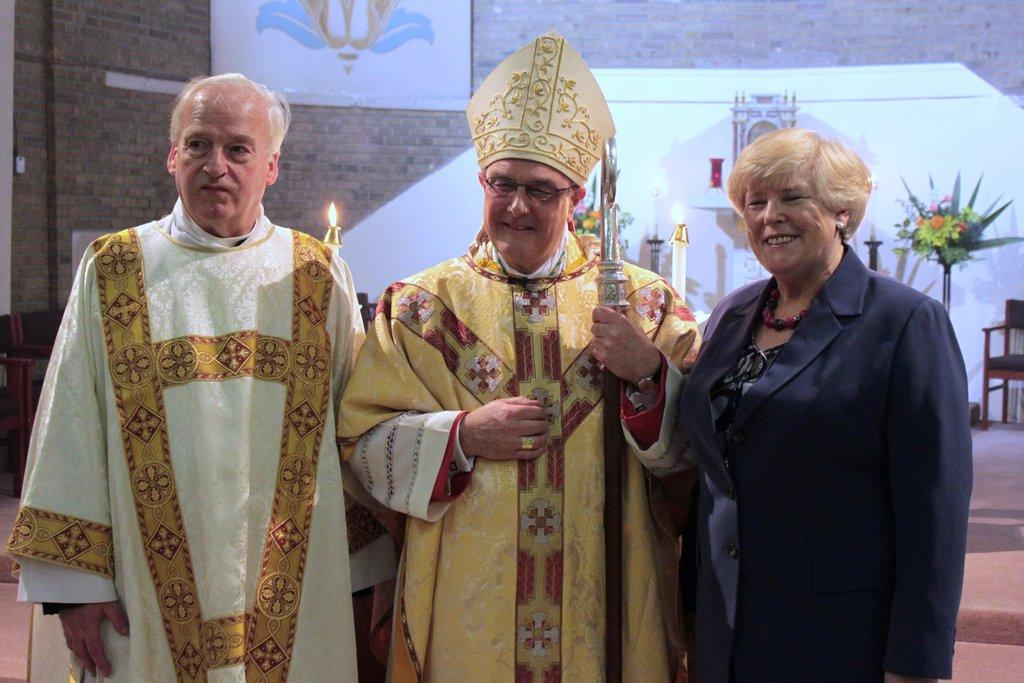How many people are in the image? There are three people in the middle of the image. What can be seen in the background of the image? There are candles, a chair, a plant with flowers, and a frame attached to a brick wall in the background of the image. Where is the tub located in the image? There is no tub present in the image. How many people are lying on the bed in the image? There is no bed present in the image. 